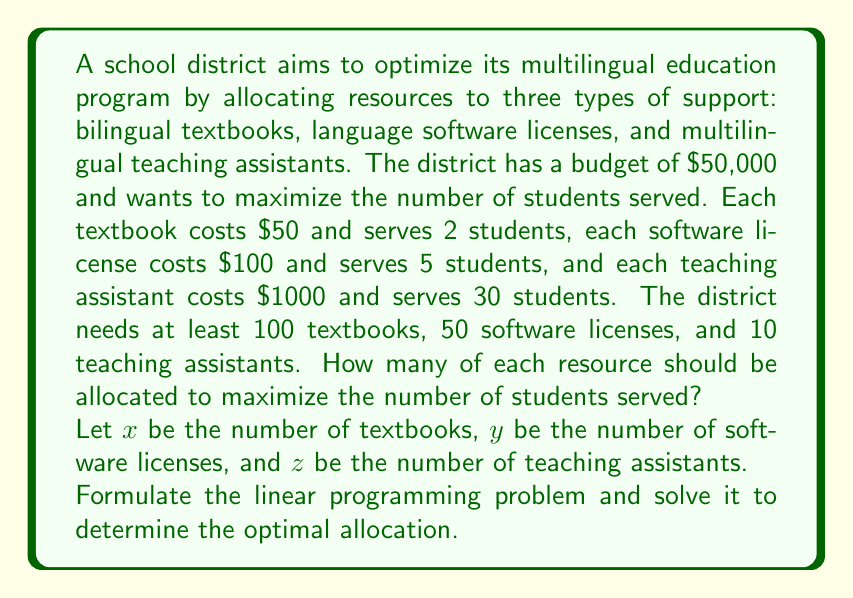Solve this math problem. To solve this problem, we'll follow these steps:

1. Formulate the linear programming problem:
   Objective function: Maximize $2x + 5y + 30z$ (number of students served)
   Subject to constraints:
   $$50x + 100y + 1000z \leq 50000$$ (budget constraint)
   $$x \geq 100$$ (minimum textbooks)
   $$y \geq 50$$ (minimum software licenses)
   $$z \geq 10$$ (minimum teaching assistants)
   $$x, y, z \geq 0$$ (non-negativity constraints)

2. Simplify the budget constraint:
   $$x + 2y + 20z \leq 1000$$

3. Set up the initial tableau:
   $$\begin{array}{c|cccc|c}
   & x & y & z & s & RHS \\
   \hline
   s & 1 & 2 & 20 & 1 & 1000 \\
   -Z & -2 & -5 & -30 & 0 & 0 \\
   \hline
   \end{array}$$

4. Identify the pivot column (most negative in -Z row): $z$

5. Calculate ratios for the pivot row:
   $1000 / 20 = 50$

6. Perform row operations to get the new tableau:
   $$\begin{array}{c|cccc|c}
   & x & y & z & s & RHS \\
   \hline
   z & 1/20 & 1/10 & 1 & 1/20 & 50 \\
   -Z & 13 & 1 & 0 & 3/2 & 1500 \\
   \hline
   \end{array}$$

7. The solution is optimal as there are no negative values in the -Z row.

8. Read the solution:
   $z = 50$ (teaching assistants)
   $x = 100$ (textbooks, from the minimum constraint)
   $y = 50$ (software licenses, from the minimum constraint)

9. Calculate the maximum number of students served:
   $2(100) + 5(50) + 30(50) = 1950$ students
Answer: 100 textbooks, 50 software licenses, 50 teaching assistants; 1950 students served 